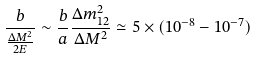Convert formula to latex. <formula><loc_0><loc_0><loc_500><loc_500>\frac { b } { \frac { \Delta M ^ { 2 } } { 2 E } } \sim \frac { b } { a } \frac { \Delta m _ { 1 2 } ^ { 2 } } { \Delta M ^ { 2 } } \simeq 5 \times ( 1 0 ^ { - 8 } - 1 0 ^ { - 7 } )</formula> 